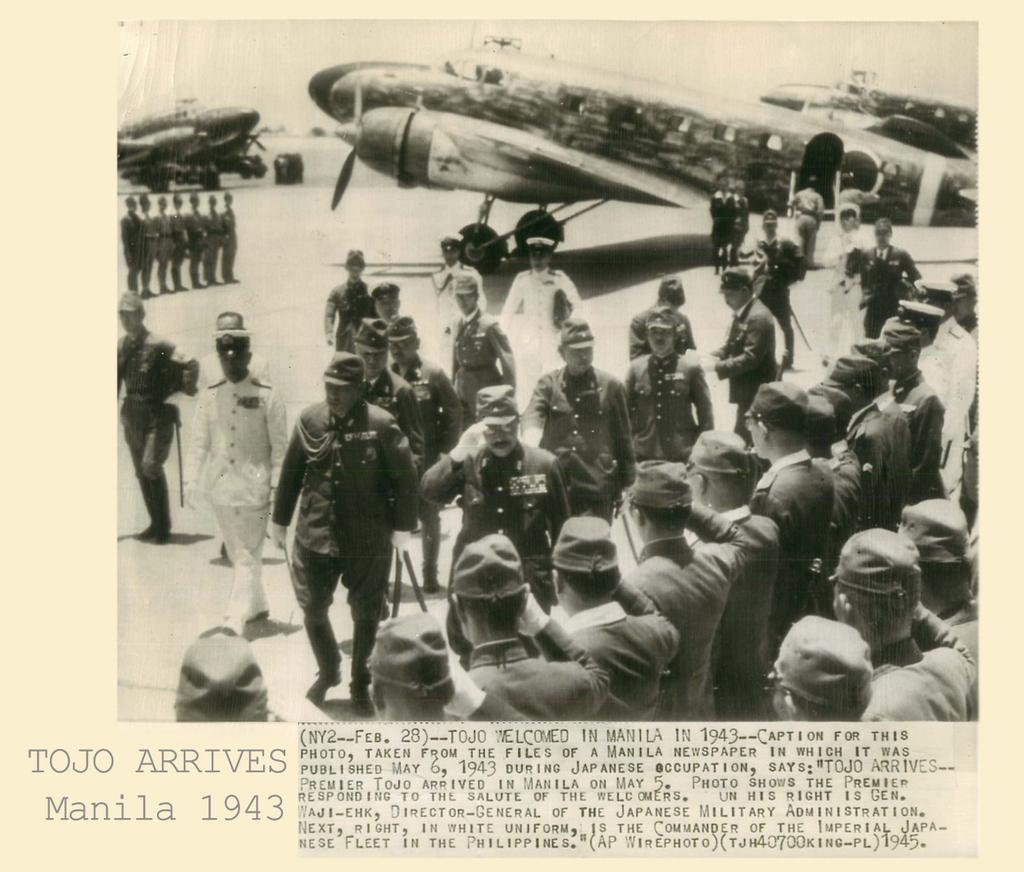What is the main subject in the foreground of the image? There is a crowd in the foreground of the image. Where is the crowd located? The crowd is on the ground. What else can be seen in the image besides the crowd? There is an aircraft visible in the image. When was the image taken? The image was taken during the day. Where was the image taken? The image was taken on a road. How many sheep can be seen grazing in the image? There are no sheep present in the image. Are there any boats visible in the image? There are no boats visible in the image. 